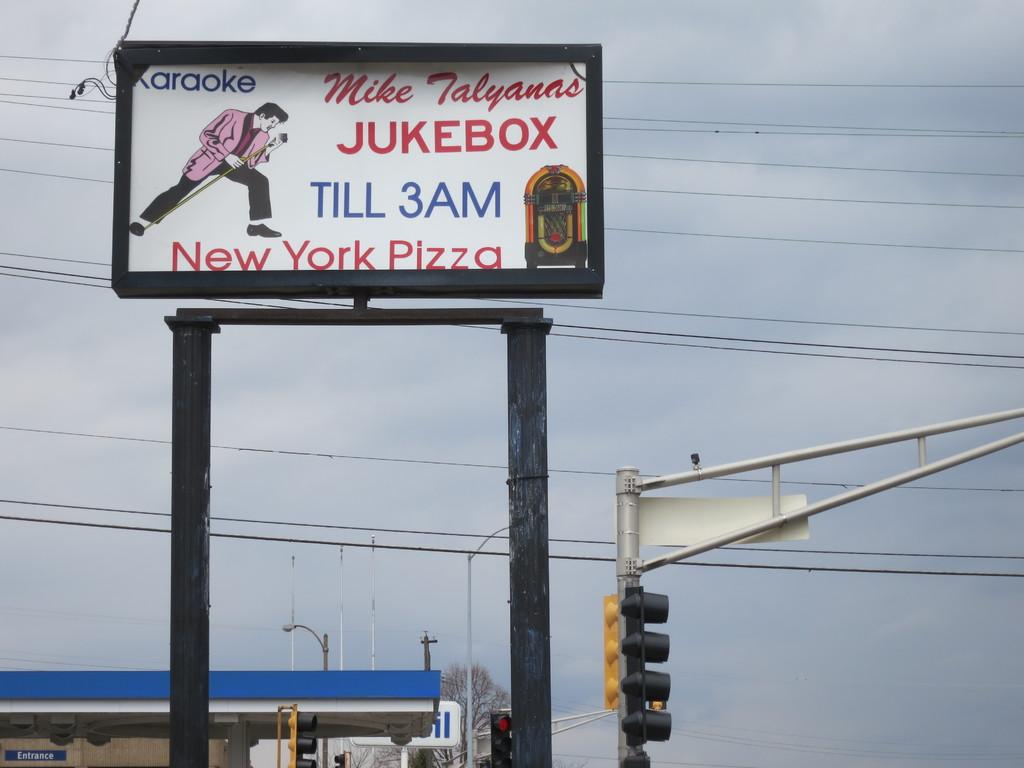<image>
Summarize the visual content of the image. Karaoke and New York Pizza are served till 3AM. 